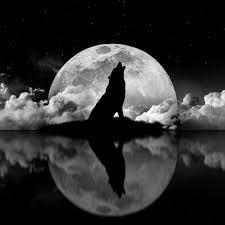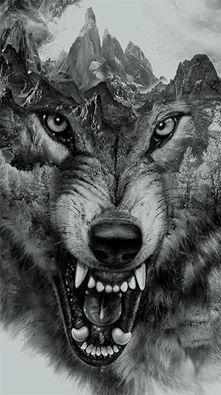The first image is the image on the left, the second image is the image on the right. For the images displayed, is the sentence "A single wolf is howling and silhouetted by the moon in one of the images." factually correct? Answer yes or no. Yes. The first image is the image on the left, the second image is the image on the right. For the images shown, is this caption "The left image includes a moon, clouds, and a howling wolf figure, and the right image depicts a forward-facing snarling wolf." true? Answer yes or no. Yes. 